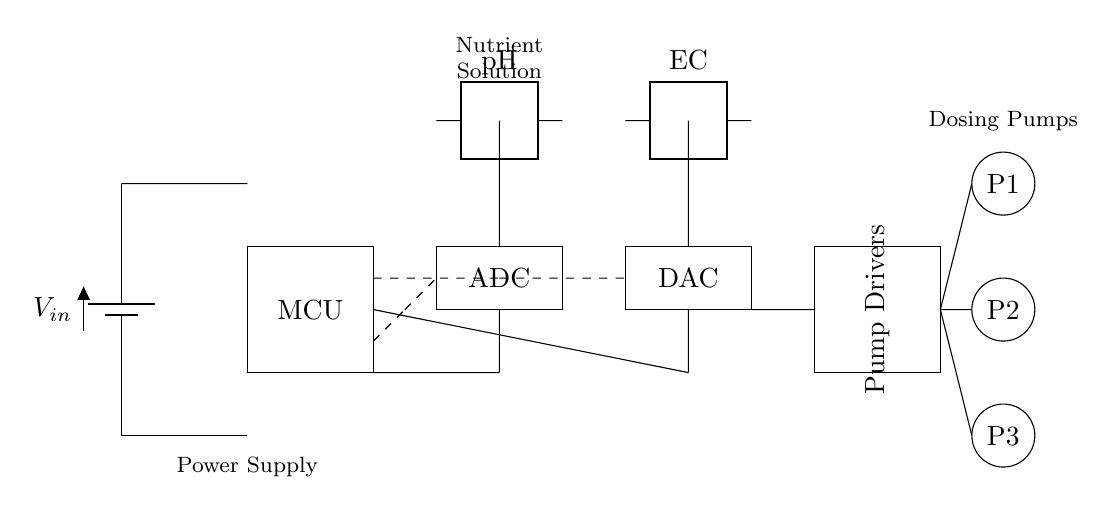What is the input voltage of this circuit? The circuit shows a battery labeled 'Vin' as the power source, indicating the input voltage.
Answer: Vin What type of sensors are included in this design? The diagram features two types of sensors: a pH sensor and an EC sensor, which are clearly labeled within the circuit.
Answer: pH and EC sensors How many pumps are connected to the system? The circuit diagram includes three pumps labeled P1, P2, and P3, indicated by the circles at the bottom right corner of the schematic.
Answer: Three pumps What is the function of the microcontroller in this circuit? The microcontroller (MCU) is responsible for controlling the signals from the sensors and managing the dosing process, as indicated by its position in the circuit.
Answer: Control signals How does the ADC influence the nutrient dosing process? The ADC converts the analog signals from the sensors (pH and EC) into digital signals that can be processed by the microcontroller, which is crucial for precision control in nutrient dosing.
Answer: Converts sensors' signals What role do the pump drivers play in this automated system? The pump drivers are positioned between the microcontroller and the pumps, responsible for amplifying control signals sent to the pumps, thereby managing their operation efficiently.
Answer: Amplifies control signals Which components are responsible for nutrient dosing in this circuit? The nutrient dosing is executed by the pumps, which are controlled by the signals received from the pump drivers, as shown in the connections.
Answer: Pumps 